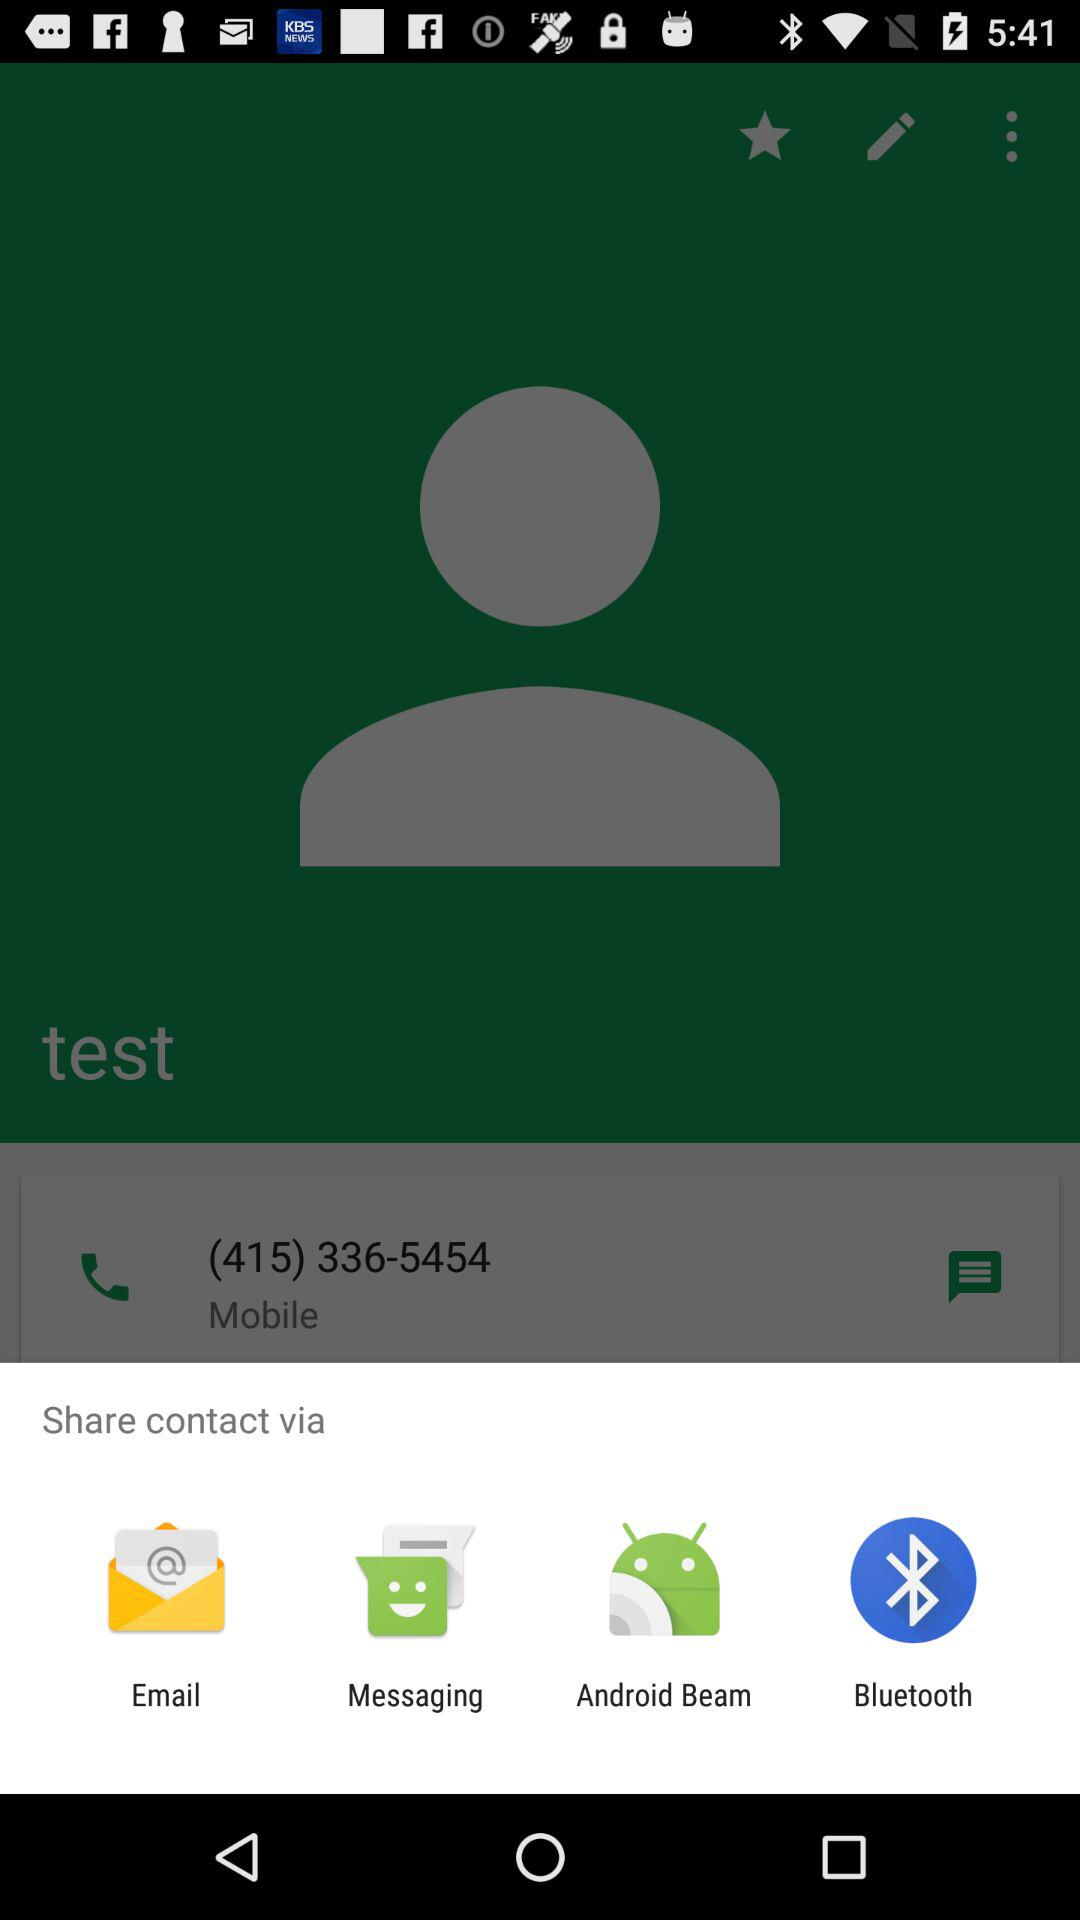How many phone numbers are in the contact?
Answer the question using a single word or phrase. 1 